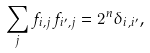Convert formula to latex. <formula><loc_0><loc_0><loc_500><loc_500>\sum _ { j } f _ { i , j } f _ { i ^ { \prime } , j } = 2 ^ { n } \delta _ { i , i ^ { \prime } } ,</formula> 